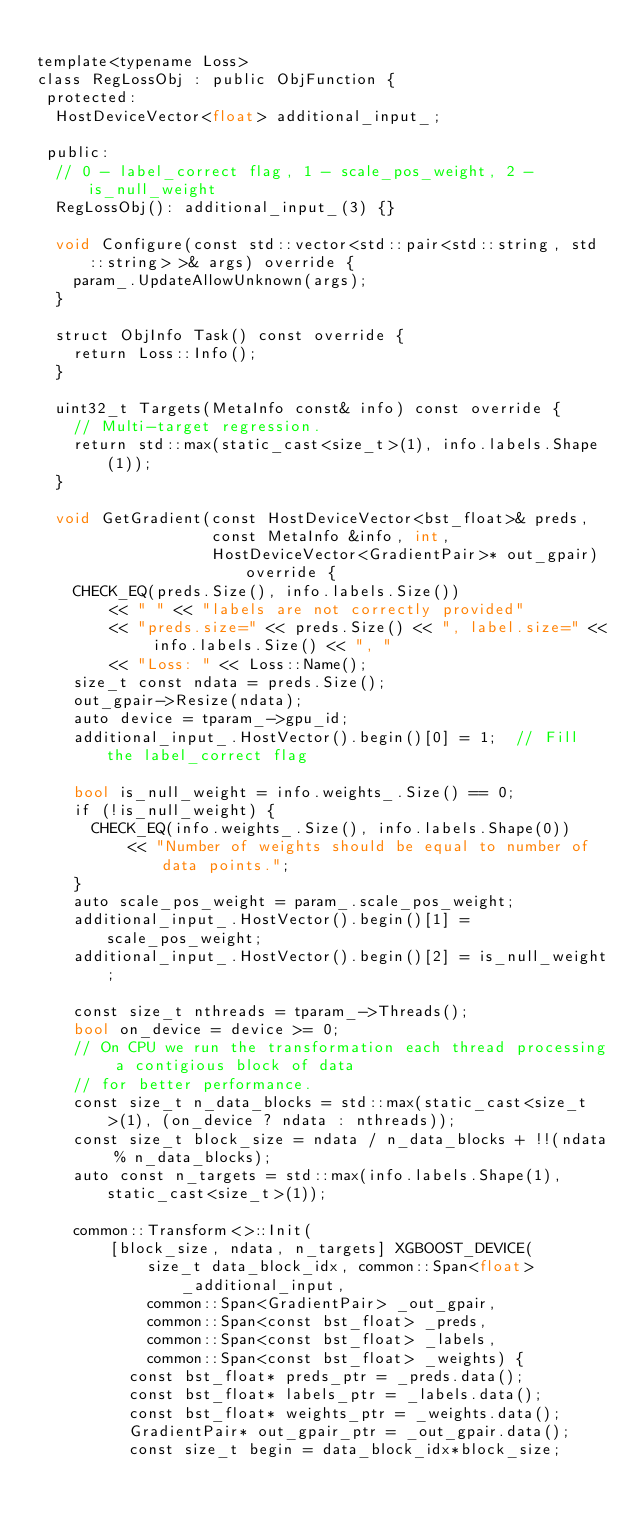<code> <loc_0><loc_0><loc_500><loc_500><_Cuda_>
template<typename Loss>
class RegLossObj : public ObjFunction {
 protected:
  HostDeviceVector<float> additional_input_;

 public:
  // 0 - label_correct flag, 1 - scale_pos_weight, 2 - is_null_weight
  RegLossObj(): additional_input_(3) {}

  void Configure(const std::vector<std::pair<std::string, std::string> >& args) override {
    param_.UpdateAllowUnknown(args);
  }

  struct ObjInfo Task() const override {
    return Loss::Info();
  }

  uint32_t Targets(MetaInfo const& info) const override {
    // Multi-target regression.
    return std::max(static_cast<size_t>(1), info.labels.Shape(1));
  }

  void GetGradient(const HostDeviceVector<bst_float>& preds,
                   const MetaInfo &info, int,
                   HostDeviceVector<GradientPair>* out_gpair) override {
    CHECK_EQ(preds.Size(), info.labels.Size())
        << " " << "labels are not correctly provided"
        << "preds.size=" << preds.Size() << ", label.size=" << info.labels.Size() << ", "
        << "Loss: " << Loss::Name();
    size_t const ndata = preds.Size();
    out_gpair->Resize(ndata);
    auto device = tparam_->gpu_id;
    additional_input_.HostVector().begin()[0] = 1;  // Fill the label_correct flag

    bool is_null_weight = info.weights_.Size() == 0;
    if (!is_null_weight) {
      CHECK_EQ(info.weights_.Size(), info.labels.Shape(0))
          << "Number of weights should be equal to number of data points.";
    }
    auto scale_pos_weight = param_.scale_pos_weight;
    additional_input_.HostVector().begin()[1] = scale_pos_weight;
    additional_input_.HostVector().begin()[2] = is_null_weight;

    const size_t nthreads = tparam_->Threads();
    bool on_device = device >= 0;
    // On CPU we run the transformation each thread processing a contigious block of data
    // for better performance.
    const size_t n_data_blocks = std::max(static_cast<size_t>(1), (on_device ? ndata : nthreads));
    const size_t block_size = ndata / n_data_blocks + !!(ndata % n_data_blocks);
    auto const n_targets = std::max(info.labels.Shape(1), static_cast<size_t>(1));

    common::Transform<>::Init(
        [block_size, ndata, n_targets] XGBOOST_DEVICE(
            size_t data_block_idx, common::Span<float> _additional_input,
            common::Span<GradientPair> _out_gpair,
            common::Span<const bst_float> _preds,
            common::Span<const bst_float> _labels,
            common::Span<const bst_float> _weights) {
          const bst_float* preds_ptr = _preds.data();
          const bst_float* labels_ptr = _labels.data();
          const bst_float* weights_ptr = _weights.data();
          GradientPair* out_gpair_ptr = _out_gpair.data();
          const size_t begin = data_block_idx*block_size;</code> 